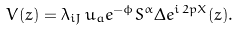<formula> <loc_0><loc_0><loc_500><loc_500>V ( z ) = \lambda _ { i J } \, u _ { a } e ^ { - \phi } { S ^ { \alpha } } \Delta e ^ { i \, 2 p X } ( z ) .</formula> 